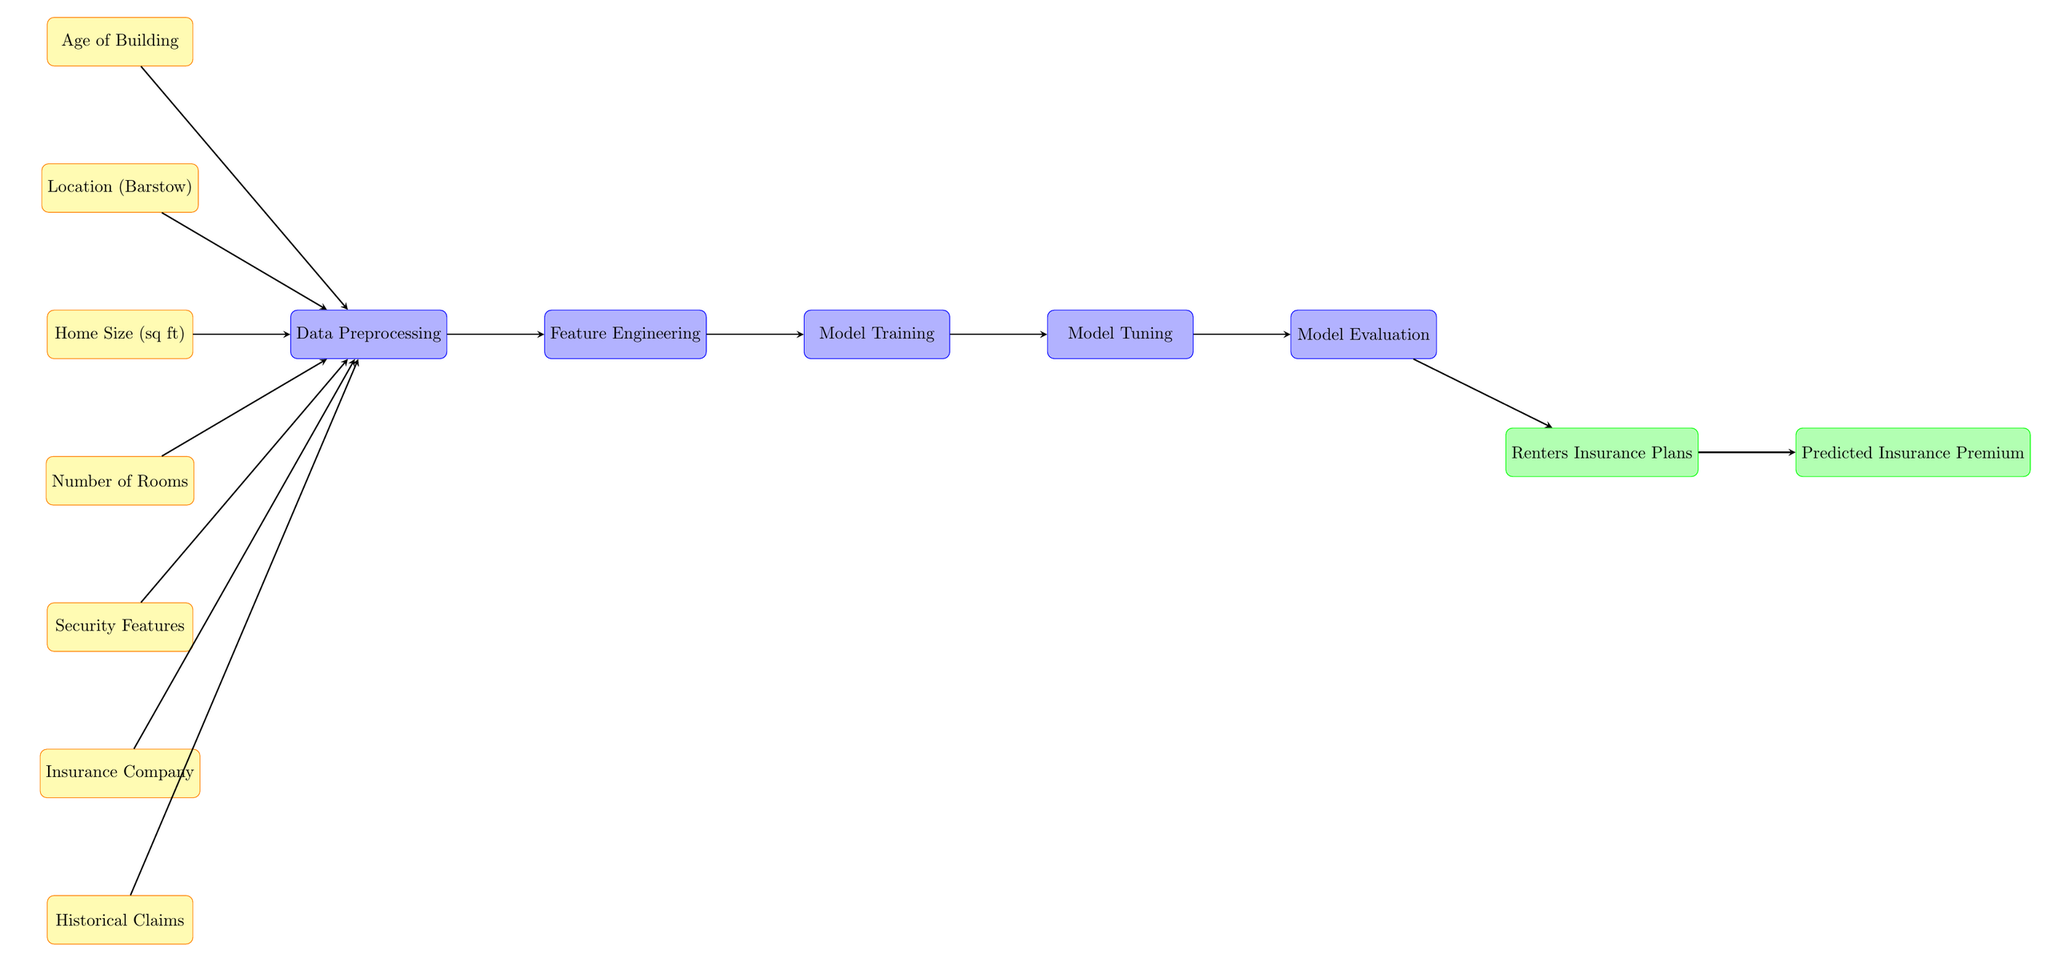What is the first input node in the diagram? The first input node listed in the diagram is "Age of Building". It is positioned at the top and is the starting point for the flow of data into the machine learning process.
Answer: Age of Building How many input nodes are present in the diagram? The diagram contains seven input nodes. They are "Age of Building," "Location (Barstow)," "Home Size (sq ft)," "Number of Rooms," "Security Features," "Insurance Company," and "Historical Claims."
Answer: 7 What is the output of the diagram? The primary outputs of the diagram are "Renters Insurance Plans" and "Predicted Insurance Premium." They are the final results produced after processing the input data.
Answer: Renters Insurance Plans, Predicted Insurance Premium Which process comes directly after Data Preprocessing? The process that follows "Data Preprocessing" is "Feature Engineering." This indicates that after the data is preprocessed, features are extracted for further model training.
Answer: Feature Engineering What influences the "Predicted Insurance Premium"? The "Predicted Insurance Premium" is influenced by "Renters Insurance Plans," which is the output produced after the evaluation of the processed data. This means that the final premium calculation relies on the generated insurance plans.
Answer: Renters Insurance Plans How does Historical Claims affect the process? "Historical Claims" is an input node that is directed towards "Data Preprocessing." Its effect on the process implies that past claims data informs the model about risk factors associated with renters insurance.
Answer: It informs risk factors What is the last process before the output nodes? The last process before reaching the output nodes is "Model Evaluation." This step tests the effectiveness of the generated models based on the features engineered from the input data before producing the output.
Answer: Model Evaluation Which input node has the highest relevance to the 'Location'? The input node with the highest relevance to 'Location' is "Location (Barstow)." It is one of the factors considered when predicting insurance costs specific to a geographical context.
Answer: Location (Barstow) 